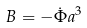<formula> <loc_0><loc_0><loc_500><loc_500>B = - \dot { \Phi } a ^ { 3 }</formula> 